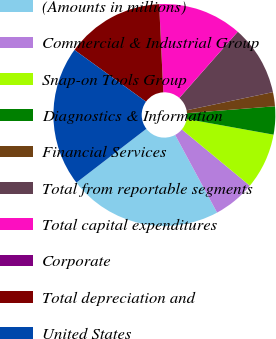Convert chart. <chart><loc_0><loc_0><loc_500><loc_500><pie_chart><fcel>(Amounts in millions)<fcel>Commercial & Industrial Group<fcel>Snap-on Tools Group<fcel>Diagnostics & Information<fcel>Financial Services<fcel>Total from reportable segments<fcel>Total capital expenditures<fcel>Corporate<fcel>Total depreciation and<fcel>United States<nl><fcel>22.44%<fcel>6.12%<fcel>8.16%<fcel>4.09%<fcel>2.05%<fcel>10.2%<fcel>12.24%<fcel>0.01%<fcel>14.28%<fcel>20.4%<nl></chart> 